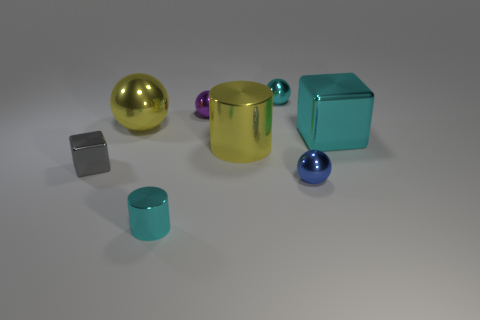Does the gray object have the same shape as the big cyan metal thing?
Offer a terse response. Yes. What size is the yellow shiny object that is the same shape as the tiny purple object?
Your answer should be very brief. Large. What is the size of the yellow thing that is on the left side of the small cyan thing in front of the purple metallic object?
Your answer should be compact. Large. Is the number of small purple balls behind the tiny purple thing the same as the number of small cyan objects to the left of the large cylinder?
Keep it short and to the point. No. There is another large thing that is the same shape as the purple thing; what color is it?
Keep it short and to the point. Yellow. What number of big things have the same color as the big shiny sphere?
Offer a very short reply. 1. There is a big yellow metallic thing that is to the right of the small metallic cylinder; is it the same shape as the large cyan metallic object?
Provide a succinct answer. No. There is a small cyan object that is in front of the gray cube that is in front of the big cyan metal object that is on the right side of the small gray thing; what is its shape?
Provide a short and direct response. Cylinder. What is the size of the yellow shiny sphere?
Keep it short and to the point. Large. What color is the large cylinder that is made of the same material as the yellow ball?
Give a very brief answer. Yellow. 